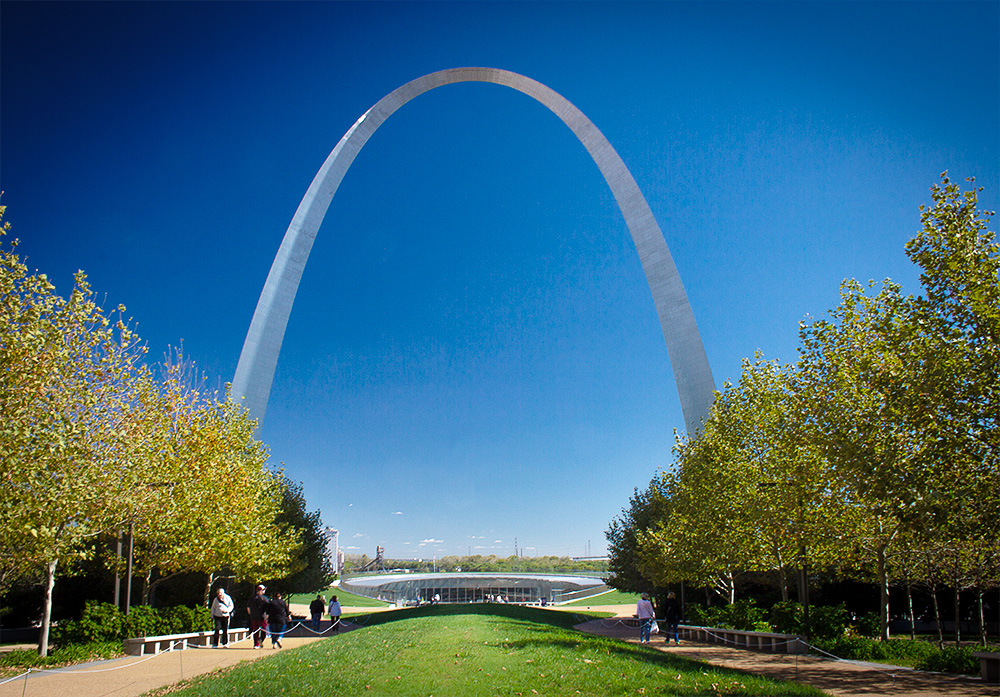Can you describe the main features of this image for me? The image features the Gateway Arch in St. Louis, Missouri, renowned for being the tallest arch globally at 630 feet. Constructed from stainless steel, the arch gleams under the sun, mirroring the clear sky. The photograph's perspective from the ground up amplifies the arch's dramatic curve and towering presence. Around the arch, the park area bustles with people, and the onset of autumn is hinted at by the slightly golden hues of the trees' leaves, adding a seasonal touch to the landscape. 